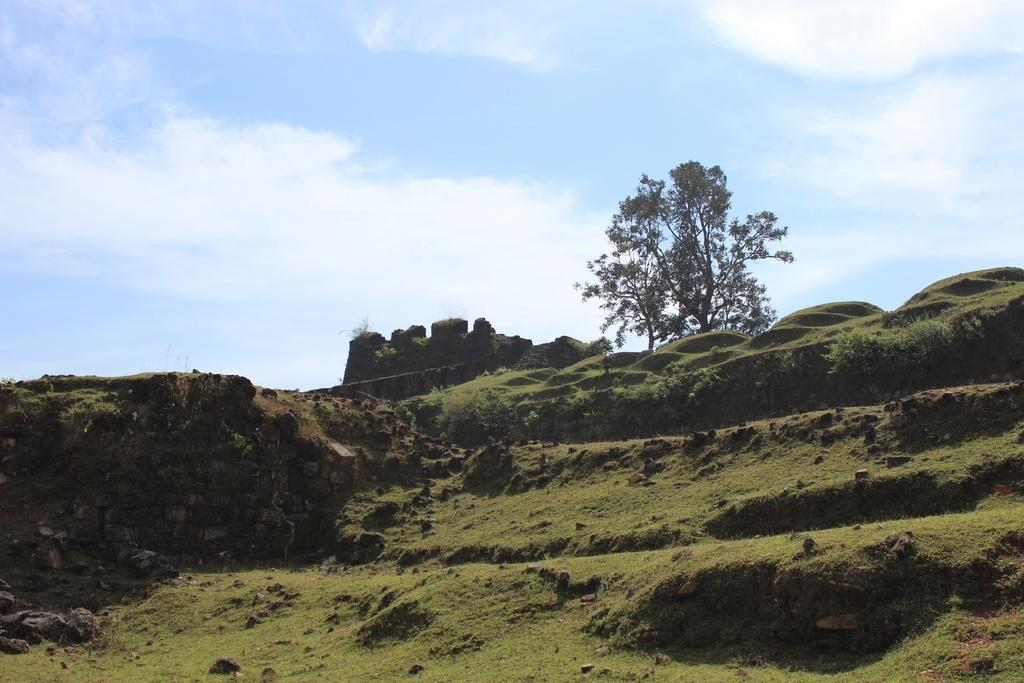What type of natural elements can be seen in the image? There are trees and rocks in the image. What is the color of the sky in the image? The sky is blue and white in color. What type of liquid can be seen spilling from the notebook in the image? There is no notebook or liquid present in the image. 